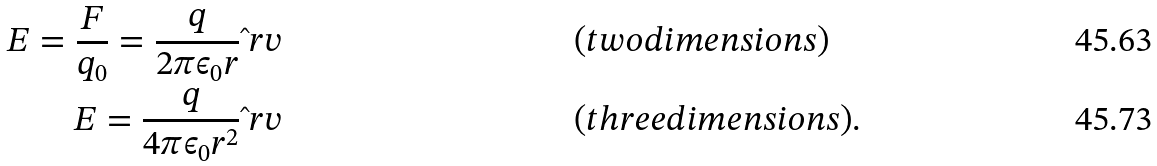<formula> <loc_0><loc_0><loc_500><loc_500>E = \frac { F } { q _ { 0 } } = \frac { q } { 2 \pi \epsilon _ { 0 } r } \hat { \ } r v & & & ( t w o d i m e n s i o n s ) \\ E = \frac { q } { 4 \pi \epsilon _ { 0 } r ^ { 2 } } \hat { \ } r v & & & ( t h r e e d i m e n s i o n s ) .</formula> 